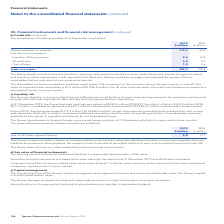According to Spirent Communications Plc's financial document, What activities does the Group perform when it closely monitors amounts due from customers? performs activities such as credit checks and reviews of payment history and has put in place appropriate credit approval limits. The document states: "p closely monitors amounts due from customers and performs activities such as credit checks and reviews of payment history and has put in place approp..." Also, What is the receivables' provision based on? expected credit losses. The document states: "The receivables’ provision is based on expected credit losses. The movement on the provision during the year is given in note 20. The value of impaire..." Also, What are the composition of trade receivables which are past due but not impaired? The document contains multiple relevant values: Less than 30 days overdue, 30 to 60 days, Over 60 days. From the document: "– Less than 30 days overdue 8.6 16.8 – Over 60 days 1.2 3.6 – 30 to 60 days 3.6 3.2..." Additionally, In which year was the amount of trade receivables larger? According to the financial document, 2019. The relevant text states: "2019 2018..." Also, can you calculate: What was the change in trade receivables? Based on the calculation: 128.7-123.4, the result is 5.3 (in millions). This is based on the information: "Trade receivables 128.7 123.4 Trade receivables 128.7 123.4..." The key data points involved are: 123.4, 128.7. Also, can you calculate: What was the percentage change in trade receivables? To answer this question, I need to perform calculations using the financial data. The calculation is: (128.7-123.4)/123.4, which equals 4.29 (percentage). This is based on the information: "Trade receivables 128.7 123.4 Trade receivables 128.7 123.4..." The key data points involved are: 123.4, 128.7. 